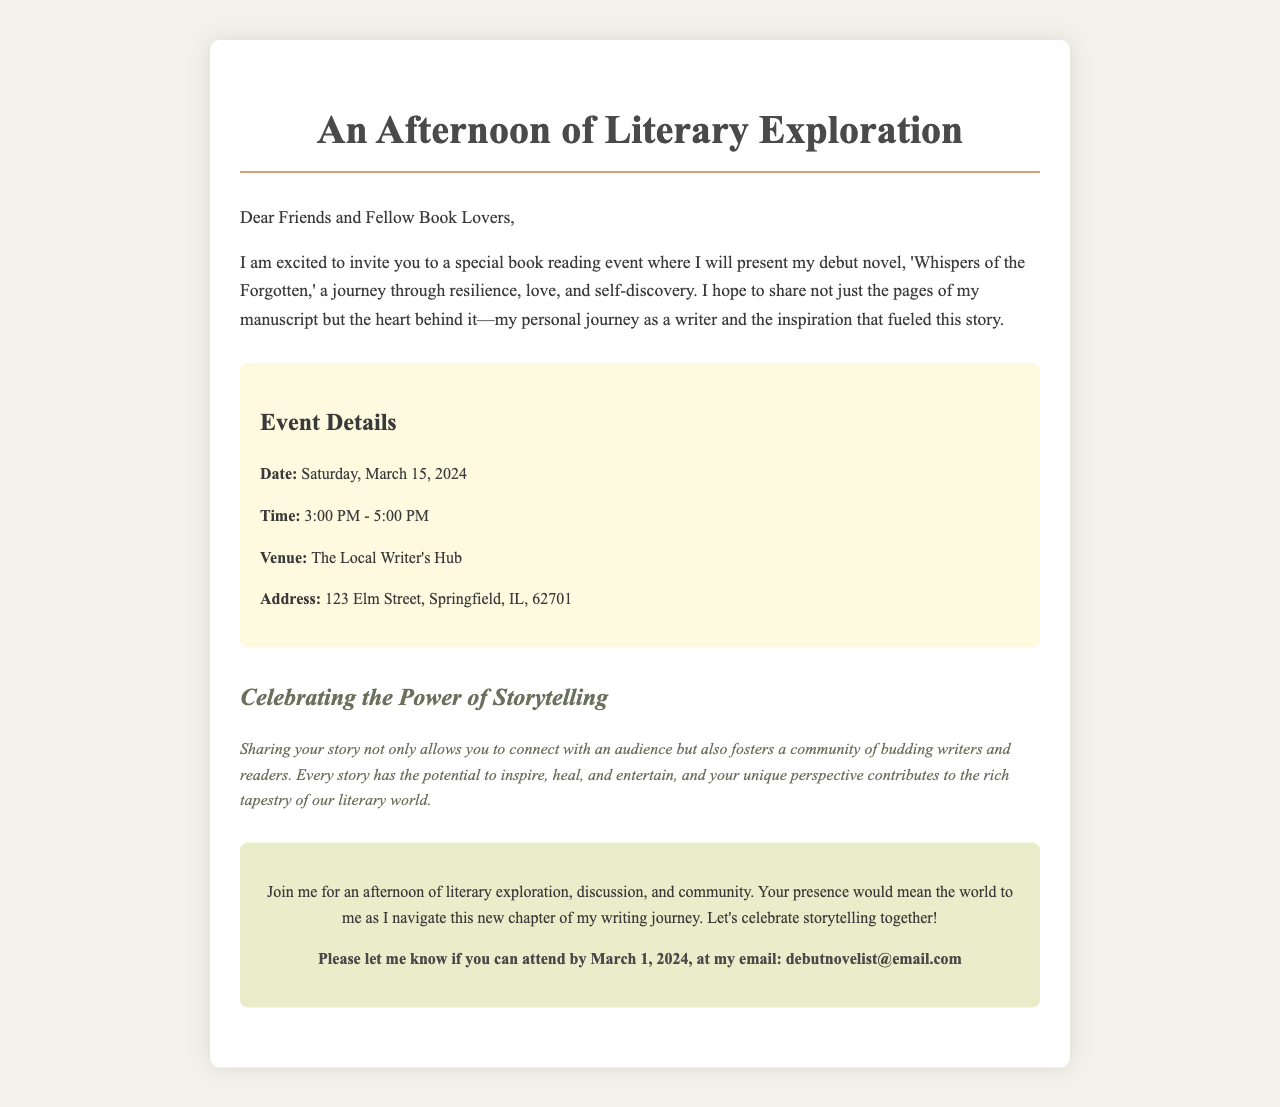What is the title of the debut novel? The title of the debut novel is mentioned in the invitation letter.
Answer: Whispers of the Forgotten When is the book reading event scheduled? The date of the book reading event is specified in the document.
Answer: Saturday, March 15, 2024 What time does the book reading event start? The start time of the event is provided in the details section.
Answer: 3:00 PM Where is the venue located? The venue where the event will take place is included in the invitation.
Answer: The Local Writer's Hub Why is sharing your story important? The significance of sharing your story is explained in a section of the document.
Answer: Connect with an audience What type of event is being held? The nature of the event is specified in the title and content of the letter.
Answer: Book reading event What is the deadline for RSVPs? The invitation letter mentions the date by which attendees should confirm their attendance.
Answer: March 1, 2024 Who should be contacted for RSVP? The invitation states the email address for confirming attendance.
Answer: debutnovelist@email.com What is the atmosphere of the event described as? The document describes the experience that attendees can expect from the gathering.
Answer: Afternoon of literary exploration 